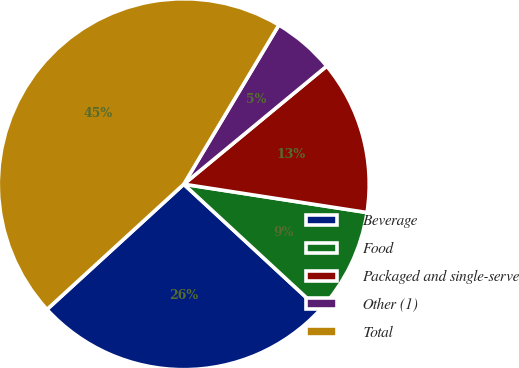<chart> <loc_0><loc_0><loc_500><loc_500><pie_chart><fcel>Beverage<fcel>Food<fcel>Packaged and single-serve<fcel>Other (1)<fcel>Total<nl><fcel>26.32%<fcel>9.44%<fcel>13.43%<fcel>5.44%<fcel>45.37%<nl></chart> 